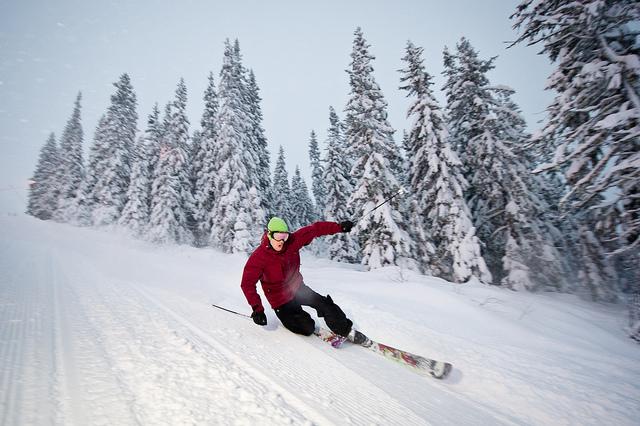What color is his hat?
Give a very brief answer. Green. What is on the trees in the background?
Answer briefly. Snow. Is the skiing in the forest?
Answer briefly. Yes. 